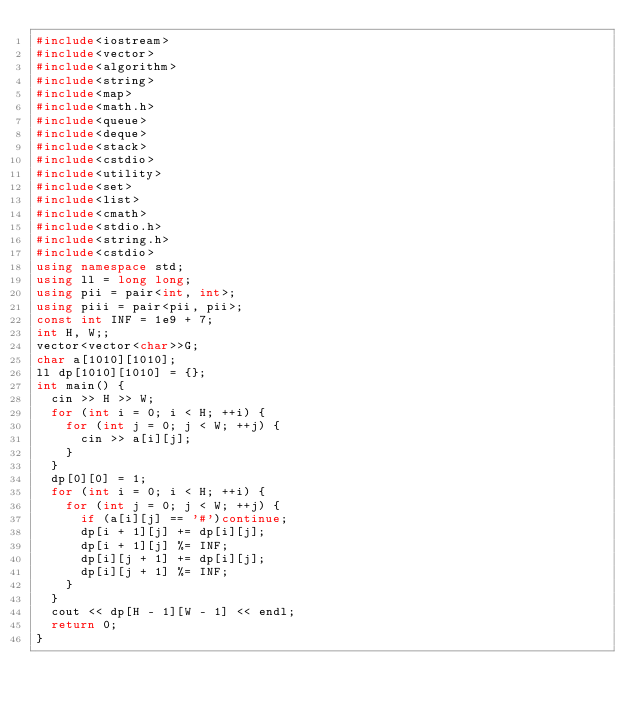Convert code to text. <code><loc_0><loc_0><loc_500><loc_500><_C++_>#include<iostream>
#include<vector>
#include<algorithm>
#include<string>
#include<map>
#include<math.h>
#include<queue>
#include<deque>
#include<stack>
#include<cstdio>
#include<utility>
#include<set>
#include<list>
#include<cmath>
#include<stdio.h>
#include<string.h>
#include<cstdio>
using namespace std;
using ll = long long;
using pii = pair<int, int>;
using piii = pair<pii, pii>;
const int INF = 1e9 + 7;
int H, W;;
vector<vector<char>>G;
char a[1010][1010];
ll dp[1010][1010] = {};
int main() {
	cin >> H >> W;
	for (int i = 0; i < H; ++i) {
		for (int j = 0; j < W; ++j) {
			cin >> a[i][j];
		}
	}
	dp[0][0] = 1;
	for (int i = 0; i < H; ++i) {
		for (int j = 0; j < W; ++j) {
			if (a[i][j] == '#')continue;
			dp[i + 1][j] += dp[i][j];
			dp[i + 1][j] %= INF;
			dp[i][j + 1] += dp[i][j];
			dp[i][j + 1] %= INF;
		}
	}
	cout << dp[H - 1][W - 1] << endl;
	return 0;
}</code> 